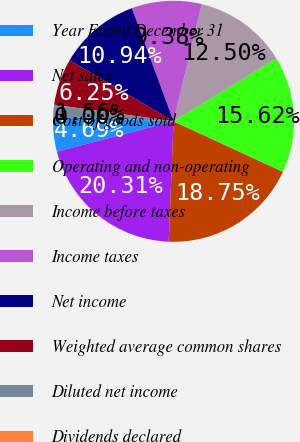<chart> <loc_0><loc_0><loc_500><loc_500><pie_chart><fcel>Year Ended December 31<fcel>Net sales<fcel>Cost of goods sold<fcel>Operating and non-operating<fcel>Income before taxes<fcel>Income taxes<fcel>Net income<fcel>Weighted average common shares<fcel>Diluted net income<fcel>Dividends declared<nl><fcel>4.69%<fcel>20.31%<fcel>18.75%<fcel>15.62%<fcel>12.5%<fcel>9.38%<fcel>10.94%<fcel>6.25%<fcel>1.56%<fcel>0.0%<nl></chart> 